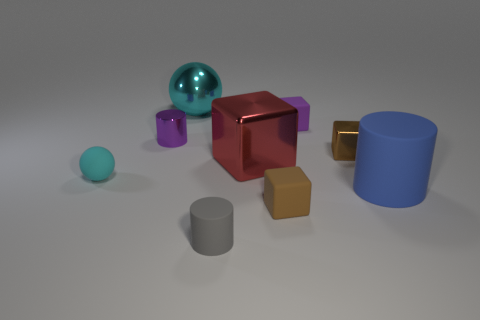Add 1 blue shiny things. How many objects exist? 10 Subtract all blocks. How many objects are left? 5 Subtract all large red blocks. Subtract all big red objects. How many objects are left? 7 Add 6 cylinders. How many cylinders are left? 9 Add 4 purple cubes. How many purple cubes exist? 5 Subtract 0 red cylinders. How many objects are left? 9 